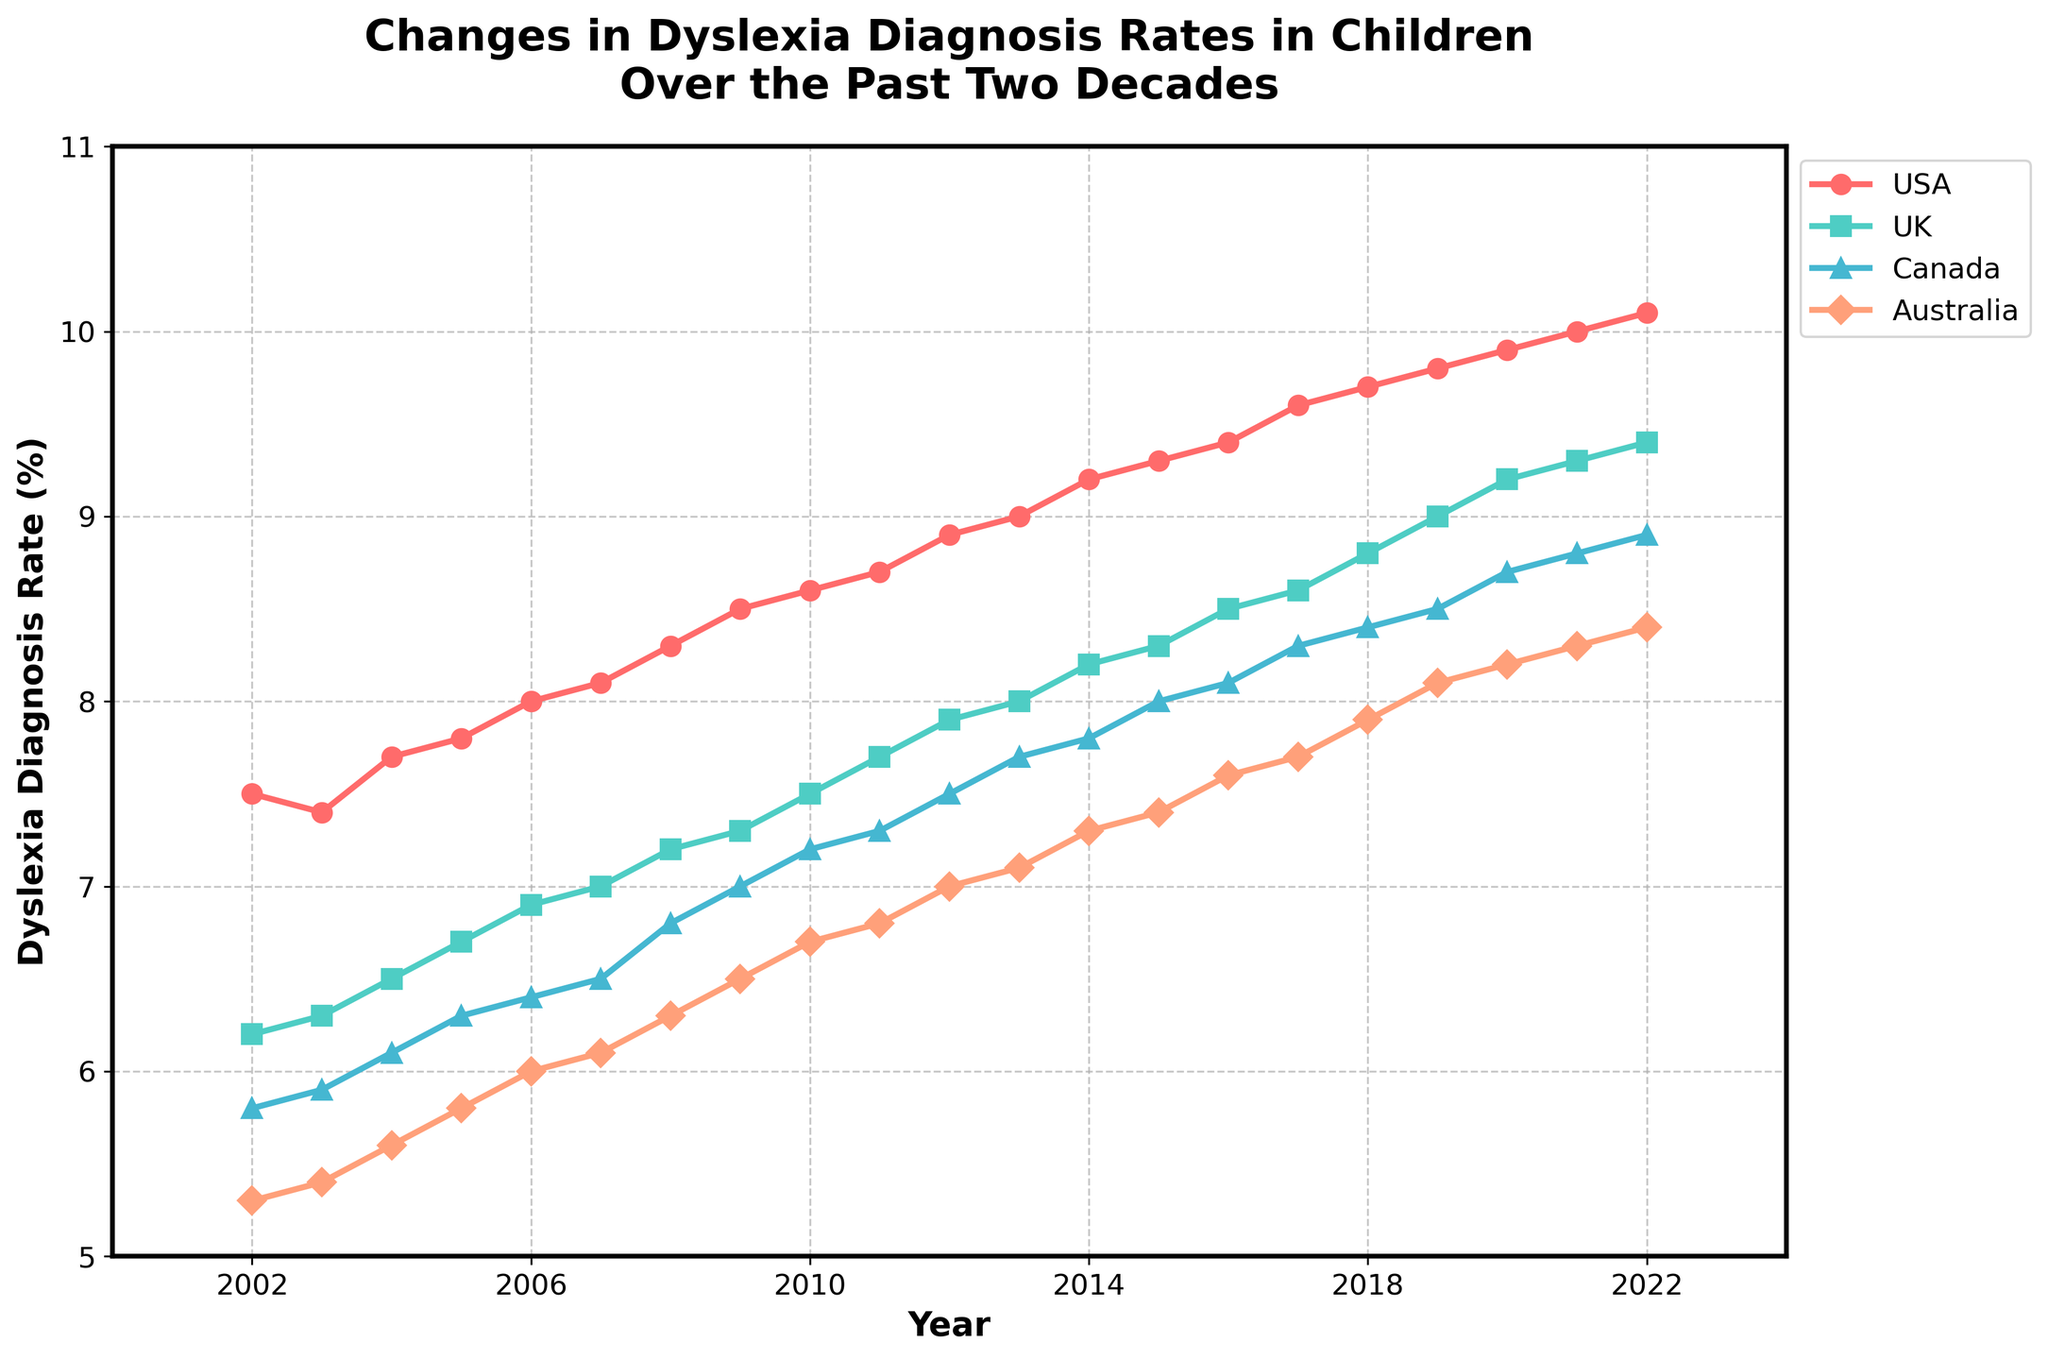What is the title of the figure? The title of the figure is displayed at the top. It reads "Changes in Dyslexia Diagnosis Rates in Children Over the Past Two Decades."
Answer: Changes in Dyslexia Diagnosis Rates in Children Over the Past Two Decades How many countries are shown in the figure? There are four different lines in the figure, each representing a different country: USA, UK, Canada, and Australia.
Answer: Four Which country had the highest dyslexia diagnosis rate in 2022, and what was the rate? Look at the end of the time series for 2022. The line representing the USA is the highest, with a rate of 10.1%.
Answer: USA, 10.1% What is the difference in dyslexia diagnosis rates between the USA and the UK in 2010? Find the values for the USA (8.6%) and the UK (7.5%) for 2010 and subtract the UK value from the USA value: 8.6% - 7.5% = 1.1%.
Answer: 1.1% Which country shows the smallest increase in dyslexia diagnosis rates from 2002 to 2022? Calculate the difference for each country from 2002 to 2022: USA (10.1 - 7.5 = 2.6), UK (9.4 - 6.2 = 3.2), Canada (8.9 - 5.8 = 3.1), Australia (8.4 - 5.3 = 3.1). The USA has the smallest increase of 2.6%.
Answer: USA Between which years does the UK show the largest annual increase in dyslexia diagnosis rates? Examine the gradients or differences between consecutive years for the UK. From 2018 (8.8%) to 2019 (9.0%) shows the largest annual increase of 0.2%.
Answer: 2018 to 2019 What year did the USA first surpass the 9% diagnosis rate? Follow the USA's time series line to see when it first crosses the 9% threshold. In 2012, the USA reached 8.9%, and in 2013, it surpassed 9% with a rate of 9.0%.
Answer: 2013 Which country has the steepest upward trend in dyslexia diagnosis rates, and how can you tell? Compare the slopes or gradients of each country's line throughout the figure. The USA line has the steepest upward trend, indicating the largest increase over time.
Answer: USA How do the dyslexia diagnosis rates of Canada and Australia compare in 2015? Look at the data points for 2015. Canada's rate is 8.0%, and Australia's rate is 7.4%. Canada has a higher rate.
Answer: Canada’s rate is higher than Australia’s What pattern can you observe in the dyslexia diagnosis rates for the USA from 2002 to 2022? Observing the time series for the USA, there is a consistent upward trend in the dyslexia diagnosis rate, increasing steadily from 7.5% to 10.1%.
Answer: Consistent upward trend 